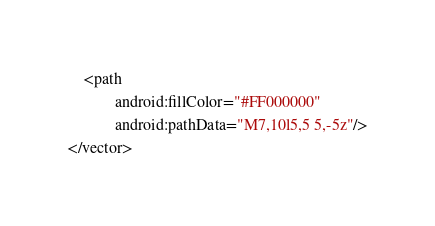Convert code to text. <code><loc_0><loc_0><loc_500><loc_500><_XML_>    <path
            android:fillColor="#FF000000"
            android:pathData="M7,10l5,5 5,-5z"/>
</vector>
</code> 